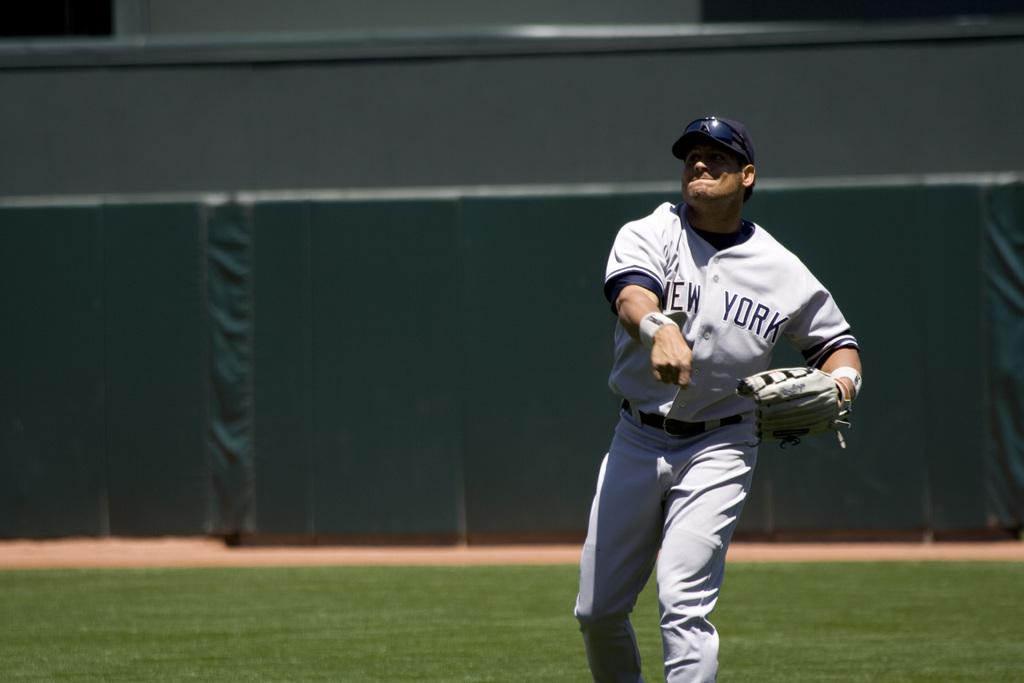Provide a one-sentence caption for the provided image. A New York baseball player has just thrown a ball with his right hand. 